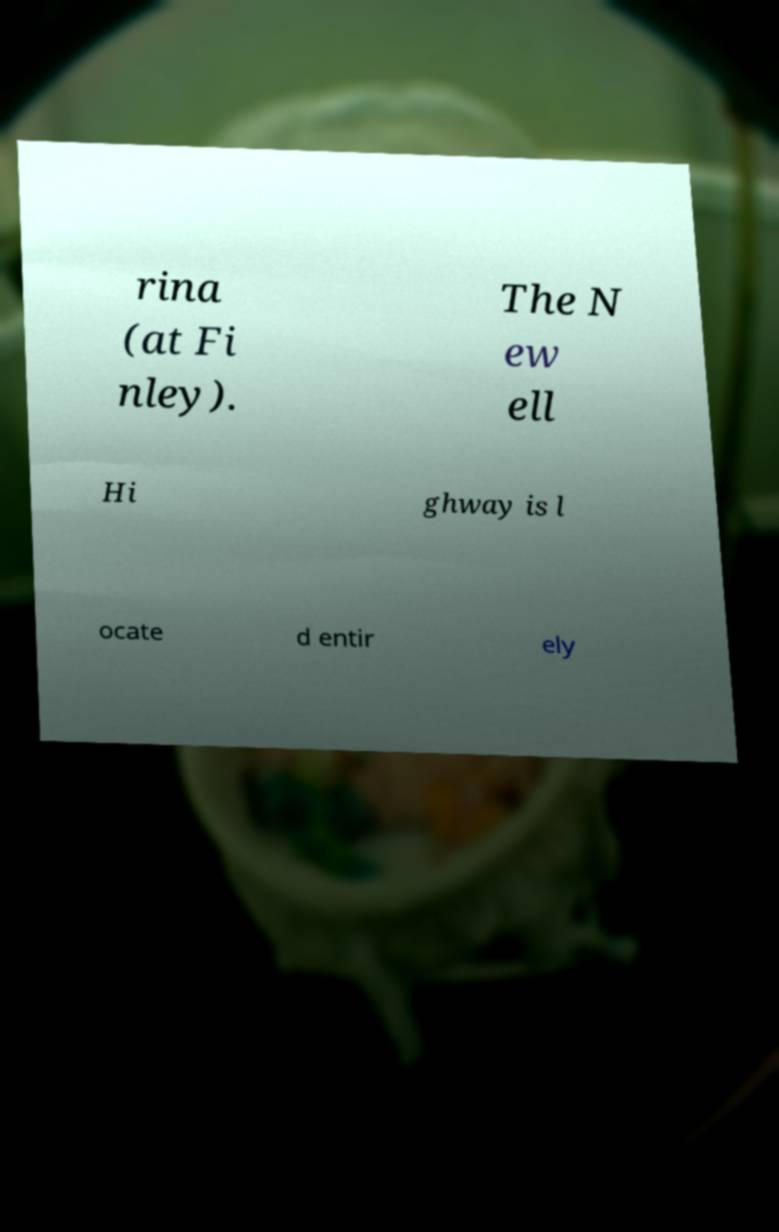Can you accurately transcribe the text from the provided image for me? rina (at Fi nley). The N ew ell Hi ghway is l ocate d entir ely 